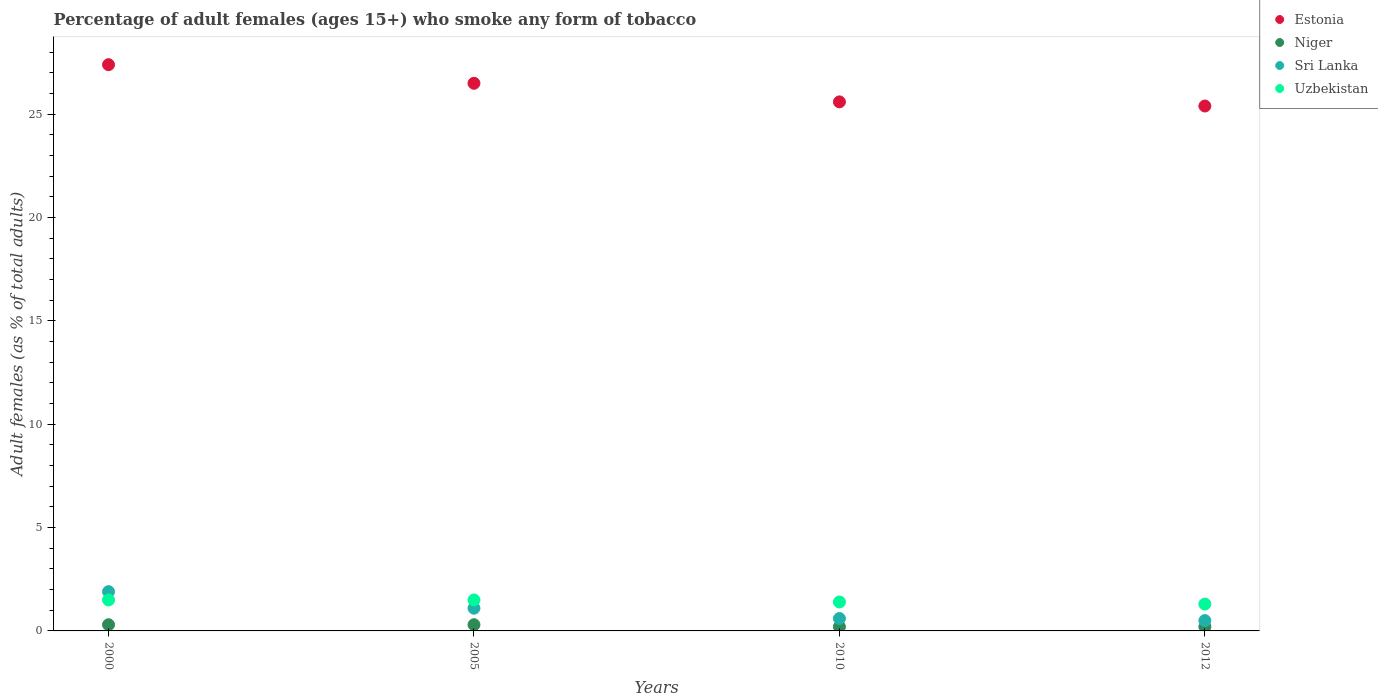How many different coloured dotlines are there?
Offer a terse response. 4. Is the number of dotlines equal to the number of legend labels?
Provide a succinct answer. Yes. Across all years, what is the maximum percentage of adult females who smoke in Sri Lanka?
Provide a short and direct response. 1.9. Across all years, what is the minimum percentage of adult females who smoke in Uzbekistan?
Make the answer very short. 1.3. In which year was the percentage of adult females who smoke in Niger minimum?
Provide a succinct answer. 2010. What is the difference between the percentage of adult females who smoke in Niger in 2000 and that in 2012?
Provide a succinct answer. 0.1. What is the difference between the percentage of adult females who smoke in Niger in 2010 and the percentage of adult females who smoke in Estonia in 2012?
Your answer should be very brief. -25.2. What is the average percentage of adult females who smoke in Niger per year?
Ensure brevity in your answer.  0.25. In the year 2005, what is the difference between the percentage of adult females who smoke in Uzbekistan and percentage of adult females who smoke in Sri Lanka?
Give a very brief answer. 0.4. In how many years, is the percentage of adult females who smoke in Sri Lanka greater than 25 %?
Your response must be concise. 0. What is the ratio of the percentage of adult females who smoke in Estonia in 2000 to that in 2012?
Offer a terse response. 1.08. Is the percentage of adult females who smoke in Uzbekistan in 2010 less than that in 2012?
Give a very brief answer. No. Is the difference between the percentage of adult females who smoke in Uzbekistan in 2005 and 2012 greater than the difference between the percentage of adult females who smoke in Sri Lanka in 2005 and 2012?
Your response must be concise. No. What is the difference between the highest and the lowest percentage of adult females who smoke in Niger?
Your response must be concise. 0.1. In how many years, is the percentage of adult females who smoke in Uzbekistan greater than the average percentage of adult females who smoke in Uzbekistan taken over all years?
Your response must be concise. 2. Is the sum of the percentage of adult females who smoke in Sri Lanka in 2000 and 2010 greater than the maximum percentage of adult females who smoke in Estonia across all years?
Offer a very short reply. No. Is it the case that in every year, the sum of the percentage of adult females who smoke in Uzbekistan and percentage of adult females who smoke in Sri Lanka  is greater than the percentage of adult females who smoke in Niger?
Provide a short and direct response. Yes. Is the percentage of adult females who smoke in Sri Lanka strictly greater than the percentage of adult females who smoke in Estonia over the years?
Provide a succinct answer. No. How many dotlines are there?
Your answer should be very brief. 4. Are the values on the major ticks of Y-axis written in scientific E-notation?
Offer a terse response. No. Where does the legend appear in the graph?
Your answer should be compact. Top right. What is the title of the graph?
Offer a very short reply. Percentage of adult females (ages 15+) who smoke any form of tobacco. Does "Sao Tome and Principe" appear as one of the legend labels in the graph?
Offer a terse response. No. What is the label or title of the Y-axis?
Give a very brief answer. Adult females (as % of total adults). What is the Adult females (as % of total adults) of Estonia in 2000?
Ensure brevity in your answer.  27.4. What is the Adult females (as % of total adults) of Niger in 2000?
Provide a short and direct response. 0.3. What is the Adult females (as % of total adults) of Estonia in 2005?
Give a very brief answer. 26.5. What is the Adult females (as % of total adults) of Niger in 2005?
Offer a very short reply. 0.3. What is the Adult females (as % of total adults) of Uzbekistan in 2005?
Provide a short and direct response. 1.5. What is the Adult females (as % of total adults) in Estonia in 2010?
Provide a short and direct response. 25.6. What is the Adult females (as % of total adults) of Sri Lanka in 2010?
Keep it short and to the point. 0.6. What is the Adult females (as % of total adults) of Uzbekistan in 2010?
Offer a terse response. 1.4. What is the Adult females (as % of total adults) of Estonia in 2012?
Ensure brevity in your answer.  25.4. Across all years, what is the maximum Adult females (as % of total adults) of Estonia?
Offer a terse response. 27.4. Across all years, what is the maximum Adult females (as % of total adults) in Niger?
Offer a terse response. 0.3. Across all years, what is the minimum Adult females (as % of total adults) of Estonia?
Offer a very short reply. 25.4. Across all years, what is the minimum Adult females (as % of total adults) of Niger?
Offer a terse response. 0.2. Across all years, what is the minimum Adult females (as % of total adults) of Sri Lanka?
Provide a succinct answer. 0.5. What is the total Adult females (as % of total adults) of Estonia in the graph?
Your response must be concise. 104.9. What is the total Adult females (as % of total adults) of Niger in the graph?
Offer a terse response. 1. What is the total Adult females (as % of total adults) in Sri Lanka in the graph?
Ensure brevity in your answer.  4.1. What is the difference between the Adult females (as % of total adults) in Uzbekistan in 2000 and that in 2005?
Ensure brevity in your answer.  0. What is the difference between the Adult females (as % of total adults) in Estonia in 2000 and that in 2010?
Provide a succinct answer. 1.8. What is the difference between the Adult females (as % of total adults) of Niger in 2000 and that in 2010?
Offer a very short reply. 0.1. What is the difference between the Adult females (as % of total adults) in Sri Lanka in 2000 and that in 2010?
Ensure brevity in your answer.  1.3. What is the difference between the Adult females (as % of total adults) of Estonia in 2000 and that in 2012?
Provide a succinct answer. 2. What is the difference between the Adult females (as % of total adults) in Niger in 2000 and that in 2012?
Your response must be concise. 0.1. What is the difference between the Adult females (as % of total adults) in Sri Lanka in 2000 and that in 2012?
Offer a terse response. 1.4. What is the difference between the Adult females (as % of total adults) of Uzbekistan in 2005 and that in 2010?
Your answer should be compact. 0.1. What is the difference between the Adult females (as % of total adults) in Sri Lanka in 2005 and that in 2012?
Make the answer very short. 0.6. What is the difference between the Adult females (as % of total adults) of Uzbekistan in 2005 and that in 2012?
Offer a very short reply. 0.2. What is the difference between the Adult females (as % of total adults) in Estonia in 2010 and that in 2012?
Your answer should be compact. 0.2. What is the difference between the Adult females (as % of total adults) of Niger in 2010 and that in 2012?
Offer a very short reply. 0. What is the difference between the Adult females (as % of total adults) in Sri Lanka in 2010 and that in 2012?
Keep it short and to the point. 0.1. What is the difference between the Adult females (as % of total adults) of Estonia in 2000 and the Adult females (as % of total adults) of Niger in 2005?
Provide a short and direct response. 27.1. What is the difference between the Adult females (as % of total adults) in Estonia in 2000 and the Adult females (as % of total adults) in Sri Lanka in 2005?
Your answer should be compact. 26.3. What is the difference between the Adult females (as % of total adults) in Estonia in 2000 and the Adult females (as % of total adults) in Uzbekistan in 2005?
Offer a terse response. 25.9. What is the difference between the Adult females (as % of total adults) of Niger in 2000 and the Adult females (as % of total adults) of Uzbekistan in 2005?
Your answer should be very brief. -1.2. What is the difference between the Adult females (as % of total adults) in Sri Lanka in 2000 and the Adult females (as % of total adults) in Uzbekistan in 2005?
Your answer should be compact. 0.4. What is the difference between the Adult females (as % of total adults) of Estonia in 2000 and the Adult females (as % of total adults) of Niger in 2010?
Provide a succinct answer. 27.2. What is the difference between the Adult females (as % of total adults) of Estonia in 2000 and the Adult females (as % of total adults) of Sri Lanka in 2010?
Make the answer very short. 26.8. What is the difference between the Adult females (as % of total adults) of Niger in 2000 and the Adult females (as % of total adults) of Sri Lanka in 2010?
Offer a very short reply. -0.3. What is the difference between the Adult females (as % of total adults) of Niger in 2000 and the Adult females (as % of total adults) of Uzbekistan in 2010?
Offer a very short reply. -1.1. What is the difference between the Adult females (as % of total adults) of Sri Lanka in 2000 and the Adult females (as % of total adults) of Uzbekistan in 2010?
Make the answer very short. 0.5. What is the difference between the Adult females (as % of total adults) in Estonia in 2000 and the Adult females (as % of total adults) in Niger in 2012?
Offer a terse response. 27.2. What is the difference between the Adult females (as % of total adults) of Estonia in 2000 and the Adult females (as % of total adults) of Sri Lanka in 2012?
Give a very brief answer. 26.9. What is the difference between the Adult females (as % of total adults) in Estonia in 2000 and the Adult females (as % of total adults) in Uzbekistan in 2012?
Provide a short and direct response. 26.1. What is the difference between the Adult females (as % of total adults) of Niger in 2000 and the Adult females (as % of total adults) of Sri Lanka in 2012?
Keep it short and to the point. -0.2. What is the difference between the Adult females (as % of total adults) of Niger in 2000 and the Adult females (as % of total adults) of Uzbekistan in 2012?
Keep it short and to the point. -1. What is the difference between the Adult females (as % of total adults) in Sri Lanka in 2000 and the Adult females (as % of total adults) in Uzbekistan in 2012?
Ensure brevity in your answer.  0.6. What is the difference between the Adult females (as % of total adults) of Estonia in 2005 and the Adult females (as % of total adults) of Niger in 2010?
Provide a succinct answer. 26.3. What is the difference between the Adult females (as % of total adults) of Estonia in 2005 and the Adult females (as % of total adults) of Sri Lanka in 2010?
Offer a very short reply. 25.9. What is the difference between the Adult females (as % of total adults) in Estonia in 2005 and the Adult females (as % of total adults) in Uzbekistan in 2010?
Keep it short and to the point. 25.1. What is the difference between the Adult females (as % of total adults) of Estonia in 2005 and the Adult females (as % of total adults) of Niger in 2012?
Provide a succinct answer. 26.3. What is the difference between the Adult females (as % of total adults) of Estonia in 2005 and the Adult females (as % of total adults) of Sri Lanka in 2012?
Your response must be concise. 26. What is the difference between the Adult females (as % of total adults) in Estonia in 2005 and the Adult females (as % of total adults) in Uzbekistan in 2012?
Provide a succinct answer. 25.2. What is the difference between the Adult females (as % of total adults) of Niger in 2005 and the Adult females (as % of total adults) of Sri Lanka in 2012?
Offer a terse response. -0.2. What is the difference between the Adult females (as % of total adults) in Niger in 2005 and the Adult females (as % of total adults) in Uzbekistan in 2012?
Offer a very short reply. -1. What is the difference between the Adult females (as % of total adults) of Estonia in 2010 and the Adult females (as % of total adults) of Niger in 2012?
Keep it short and to the point. 25.4. What is the difference between the Adult females (as % of total adults) of Estonia in 2010 and the Adult females (as % of total adults) of Sri Lanka in 2012?
Make the answer very short. 25.1. What is the difference between the Adult females (as % of total adults) of Estonia in 2010 and the Adult females (as % of total adults) of Uzbekistan in 2012?
Ensure brevity in your answer.  24.3. What is the difference between the Adult females (as % of total adults) of Niger in 2010 and the Adult females (as % of total adults) of Sri Lanka in 2012?
Keep it short and to the point. -0.3. What is the difference between the Adult females (as % of total adults) in Niger in 2010 and the Adult females (as % of total adults) in Uzbekistan in 2012?
Make the answer very short. -1.1. What is the average Adult females (as % of total adults) in Estonia per year?
Keep it short and to the point. 26.23. What is the average Adult females (as % of total adults) in Niger per year?
Provide a short and direct response. 0.25. What is the average Adult females (as % of total adults) in Sri Lanka per year?
Provide a short and direct response. 1.02. What is the average Adult females (as % of total adults) of Uzbekistan per year?
Your response must be concise. 1.43. In the year 2000, what is the difference between the Adult females (as % of total adults) in Estonia and Adult females (as % of total adults) in Niger?
Offer a very short reply. 27.1. In the year 2000, what is the difference between the Adult females (as % of total adults) in Estonia and Adult females (as % of total adults) in Sri Lanka?
Ensure brevity in your answer.  25.5. In the year 2000, what is the difference between the Adult females (as % of total adults) in Estonia and Adult females (as % of total adults) in Uzbekistan?
Provide a short and direct response. 25.9. In the year 2000, what is the difference between the Adult females (as % of total adults) in Niger and Adult females (as % of total adults) in Sri Lanka?
Offer a terse response. -1.6. In the year 2000, what is the difference between the Adult females (as % of total adults) in Niger and Adult females (as % of total adults) in Uzbekistan?
Your response must be concise. -1.2. In the year 2000, what is the difference between the Adult females (as % of total adults) of Sri Lanka and Adult females (as % of total adults) of Uzbekistan?
Make the answer very short. 0.4. In the year 2005, what is the difference between the Adult females (as % of total adults) in Estonia and Adult females (as % of total adults) in Niger?
Give a very brief answer. 26.2. In the year 2005, what is the difference between the Adult females (as % of total adults) in Estonia and Adult females (as % of total adults) in Sri Lanka?
Ensure brevity in your answer.  25.4. In the year 2005, what is the difference between the Adult females (as % of total adults) in Niger and Adult females (as % of total adults) in Uzbekistan?
Make the answer very short. -1.2. In the year 2005, what is the difference between the Adult females (as % of total adults) in Sri Lanka and Adult females (as % of total adults) in Uzbekistan?
Your answer should be very brief. -0.4. In the year 2010, what is the difference between the Adult females (as % of total adults) of Estonia and Adult females (as % of total adults) of Niger?
Make the answer very short. 25.4. In the year 2010, what is the difference between the Adult females (as % of total adults) of Estonia and Adult females (as % of total adults) of Uzbekistan?
Offer a terse response. 24.2. In the year 2012, what is the difference between the Adult females (as % of total adults) of Estonia and Adult females (as % of total adults) of Niger?
Provide a succinct answer. 25.2. In the year 2012, what is the difference between the Adult females (as % of total adults) of Estonia and Adult females (as % of total adults) of Sri Lanka?
Your response must be concise. 24.9. In the year 2012, what is the difference between the Adult females (as % of total adults) in Estonia and Adult females (as % of total adults) in Uzbekistan?
Provide a succinct answer. 24.1. In the year 2012, what is the difference between the Adult females (as % of total adults) in Niger and Adult females (as % of total adults) in Sri Lanka?
Provide a short and direct response. -0.3. In the year 2012, what is the difference between the Adult females (as % of total adults) of Niger and Adult females (as % of total adults) of Uzbekistan?
Provide a succinct answer. -1.1. In the year 2012, what is the difference between the Adult females (as % of total adults) of Sri Lanka and Adult females (as % of total adults) of Uzbekistan?
Your answer should be compact. -0.8. What is the ratio of the Adult females (as % of total adults) in Estonia in 2000 to that in 2005?
Your answer should be compact. 1.03. What is the ratio of the Adult females (as % of total adults) of Sri Lanka in 2000 to that in 2005?
Make the answer very short. 1.73. What is the ratio of the Adult females (as % of total adults) of Uzbekistan in 2000 to that in 2005?
Ensure brevity in your answer.  1. What is the ratio of the Adult females (as % of total adults) of Estonia in 2000 to that in 2010?
Your answer should be very brief. 1.07. What is the ratio of the Adult females (as % of total adults) of Sri Lanka in 2000 to that in 2010?
Provide a short and direct response. 3.17. What is the ratio of the Adult females (as % of total adults) in Uzbekistan in 2000 to that in 2010?
Your answer should be very brief. 1.07. What is the ratio of the Adult females (as % of total adults) of Estonia in 2000 to that in 2012?
Provide a short and direct response. 1.08. What is the ratio of the Adult females (as % of total adults) in Sri Lanka in 2000 to that in 2012?
Provide a succinct answer. 3.8. What is the ratio of the Adult females (as % of total adults) of Uzbekistan in 2000 to that in 2012?
Offer a very short reply. 1.15. What is the ratio of the Adult females (as % of total adults) in Estonia in 2005 to that in 2010?
Provide a succinct answer. 1.04. What is the ratio of the Adult females (as % of total adults) in Sri Lanka in 2005 to that in 2010?
Your response must be concise. 1.83. What is the ratio of the Adult females (as % of total adults) of Uzbekistan in 2005 to that in 2010?
Your answer should be very brief. 1.07. What is the ratio of the Adult females (as % of total adults) in Estonia in 2005 to that in 2012?
Make the answer very short. 1.04. What is the ratio of the Adult females (as % of total adults) of Sri Lanka in 2005 to that in 2012?
Ensure brevity in your answer.  2.2. What is the ratio of the Adult females (as % of total adults) in Uzbekistan in 2005 to that in 2012?
Provide a succinct answer. 1.15. What is the ratio of the Adult females (as % of total adults) in Estonia in 2010 to that in 2012?
Offer a terse response. 1.01. What is the ratio of the Adult females (as % of total adults) in Niger in 2010 to that in 2012?
Provide a short and direct response. 1. What is the ratio of the Adult females (as % of total adults) in Sri Lanka in 2010 to that in 2012?
Offer a terse response. 1.2. What is the difference between the highest and the second highest Adult females (as % of total adults) in Estonia?
Keep it short and to the point. 0.9. What is the difference between the highest and the second highest Adult females (as % of total adults) of Niger?
Your response must be concise. 0. What is the difference between the highest and the second highest Adult females (as % of total adults) in Sri Lanka?
Provide a short and direct response. 0.8. What is the difference between the highest and the second highest Adult females (as % of total adults) in Uzbekistan?
Your answer should be compact. 0. What is the difference between the highest and the lowest Adult females (as % of total adults) of Estonia?
Offer a terse response. 2. What is the difference between the highest and the lowest Adult females (as % of total adults) of Niger?
Keep it short and to the point. 0.1. What is the difference between the highest and the lowest Adult females (as % of total adults) of Uzbekistan?
Provide a succinct answer. 0.2. 